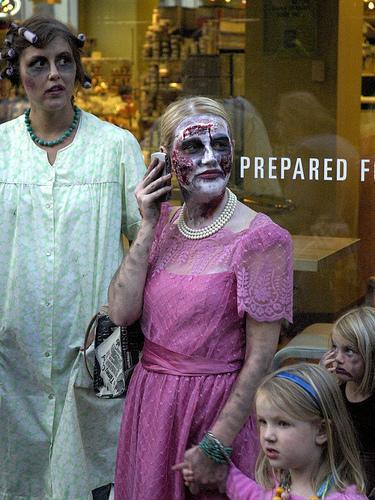How many people are there?
Give a very brief answer. 4. How many children are there?
Give a very brief answer. 2. 